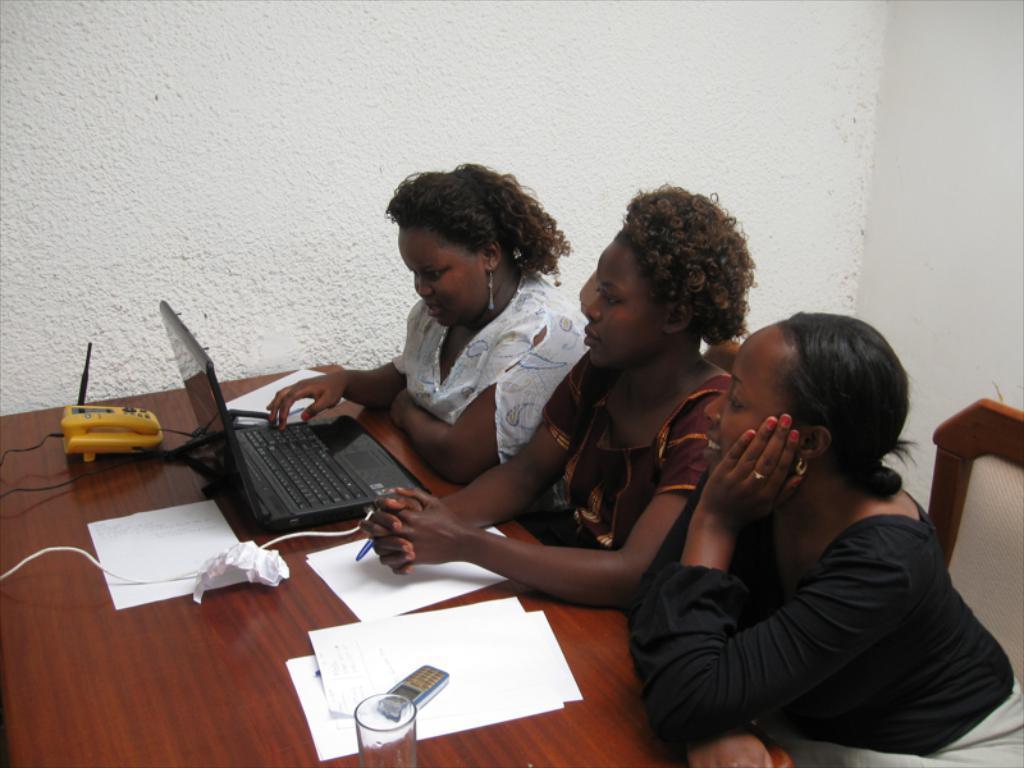In one or two sentences, can you explain what this image depicts? In this picture there are three women sitting in the chairs in front of a table on which some papers, mobile, glasses and a telephone along with a laptop were present. In the background there is a wall. 